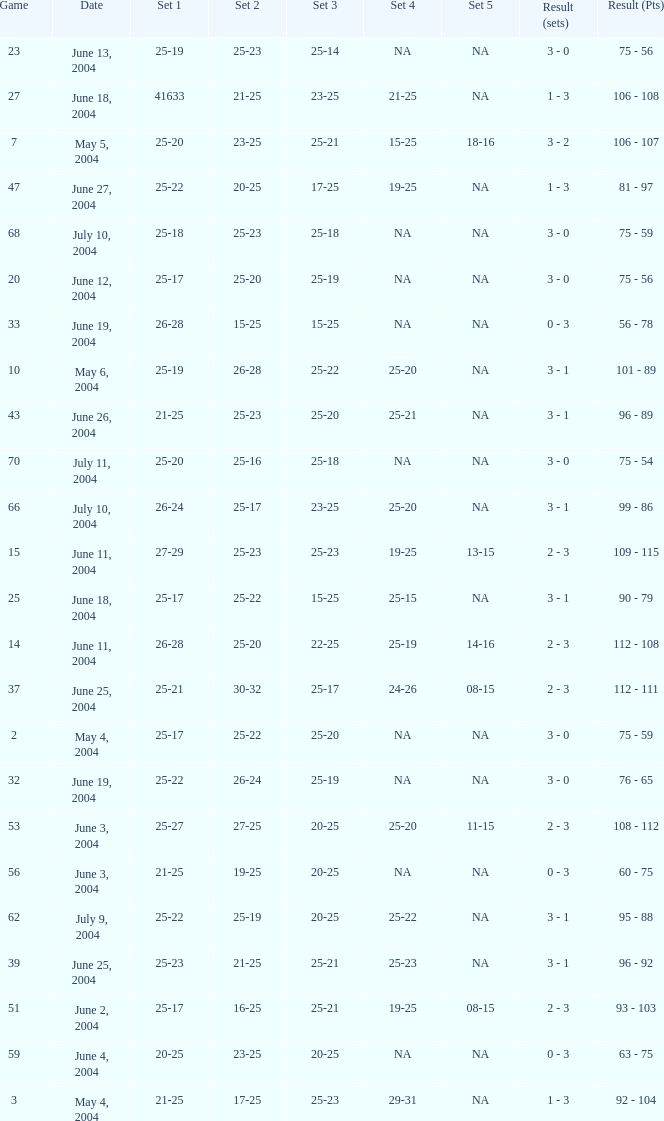What is the result of the game with a set 1 of 26-24? 99 - 86. 